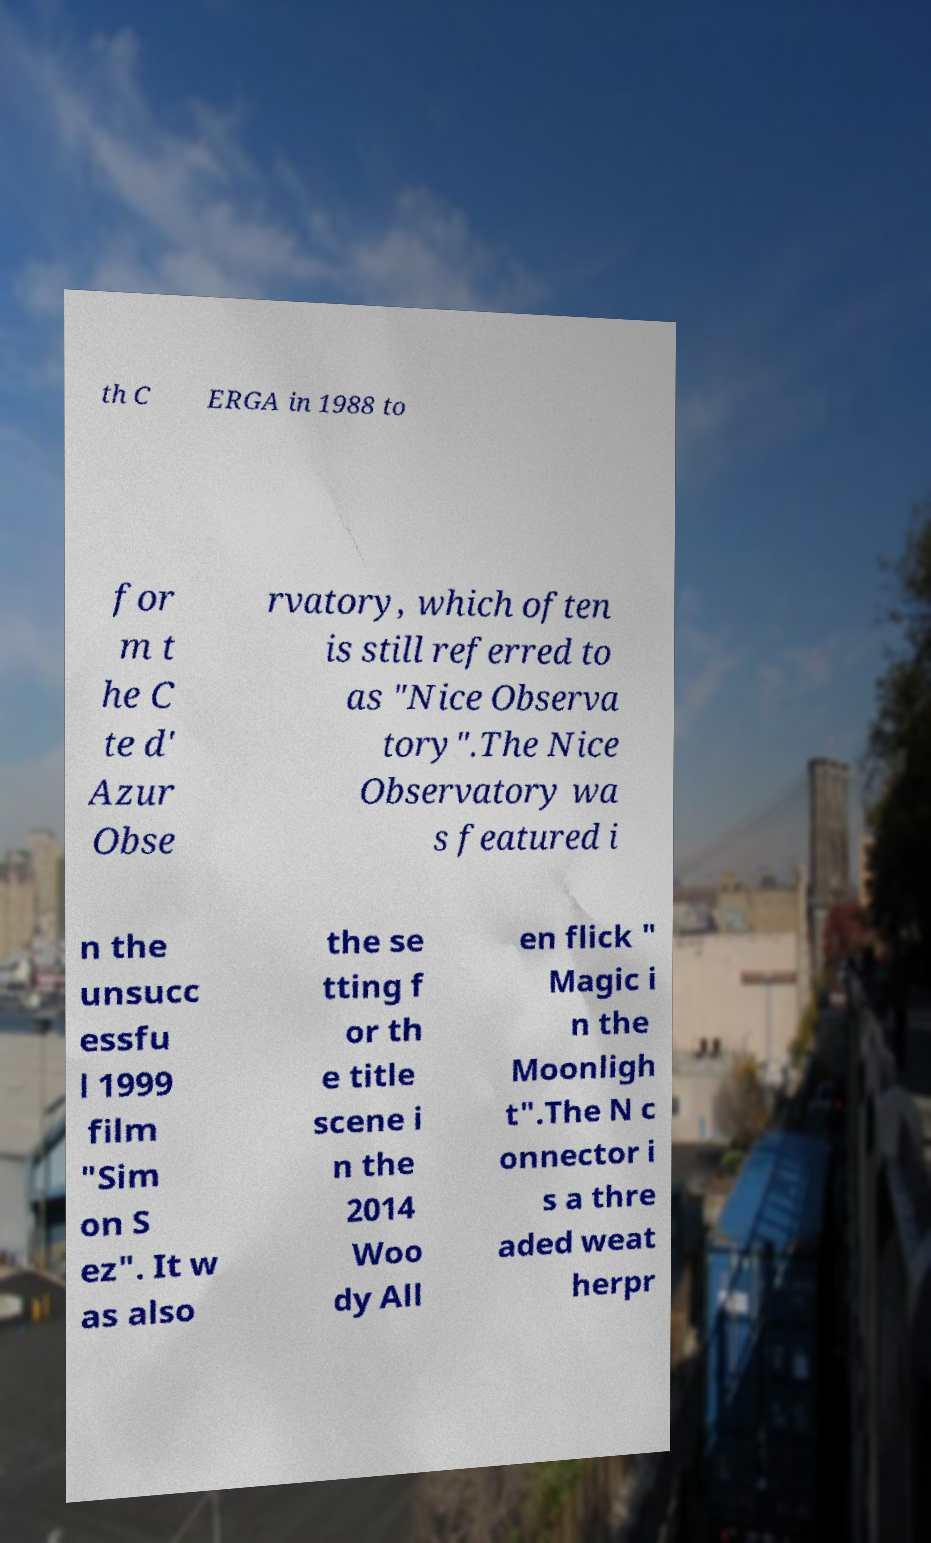Please identify and transcribe the text found in this image. th C ERGA in 1988 to for m t he C te d' Azur Obse rvatory, which often is still referred to as "Nice Observa tory".The Nice Observatory wa s featured i n the unsucc essfu l 1999 film "Sim on S ez". It w as also the se tting f or th e title scene i n the 2014 Woo dy All en flick " Magic i n the Moonligh t".The N c onnector i s a thre aded weat herpr 